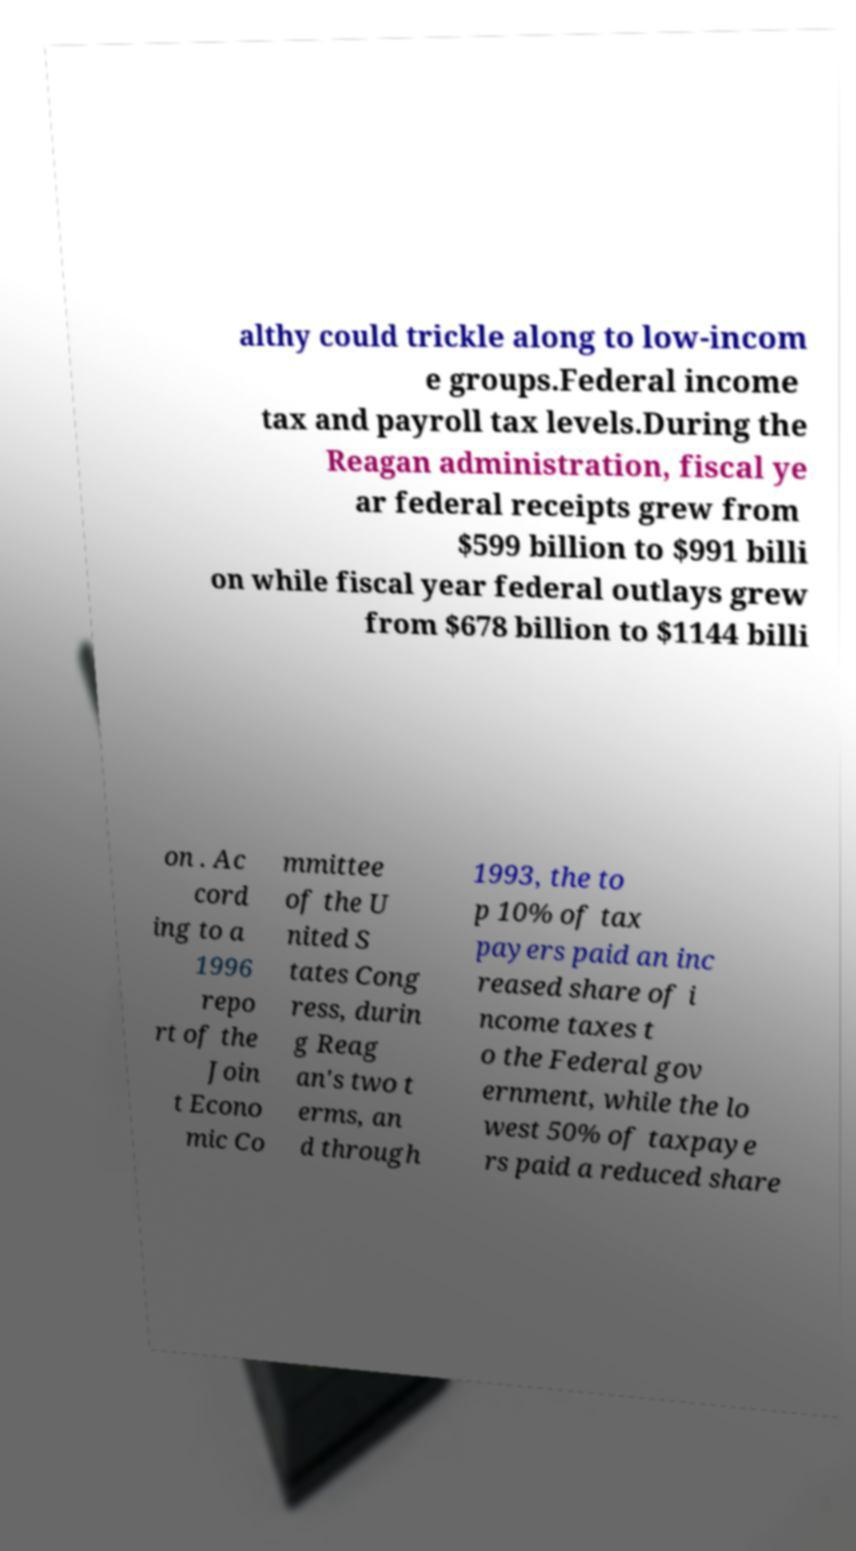Please identify and transcribe the text found in this image. althy could trickle along to low-incom e groups.Federal income tax and payroll tax levels.During the Reagan administration, fiscal ye ar federal receipts grew from $599 billion to $991 billi on while fiscal year federal outlays grew from $678 billion to $1144 billi on . Ac cord ing to a 1996 repo rt of the Join t Econo mic Co mmittee of the U nited S tates Cong ress, durin g Reag an's two t erms, an d through 1993, the to p 10% of tax payers paid an inc reased share of i ncome taxes t o the Federal gov ernment, while the lo west 50% of taxpaye rs paid a reduced share 